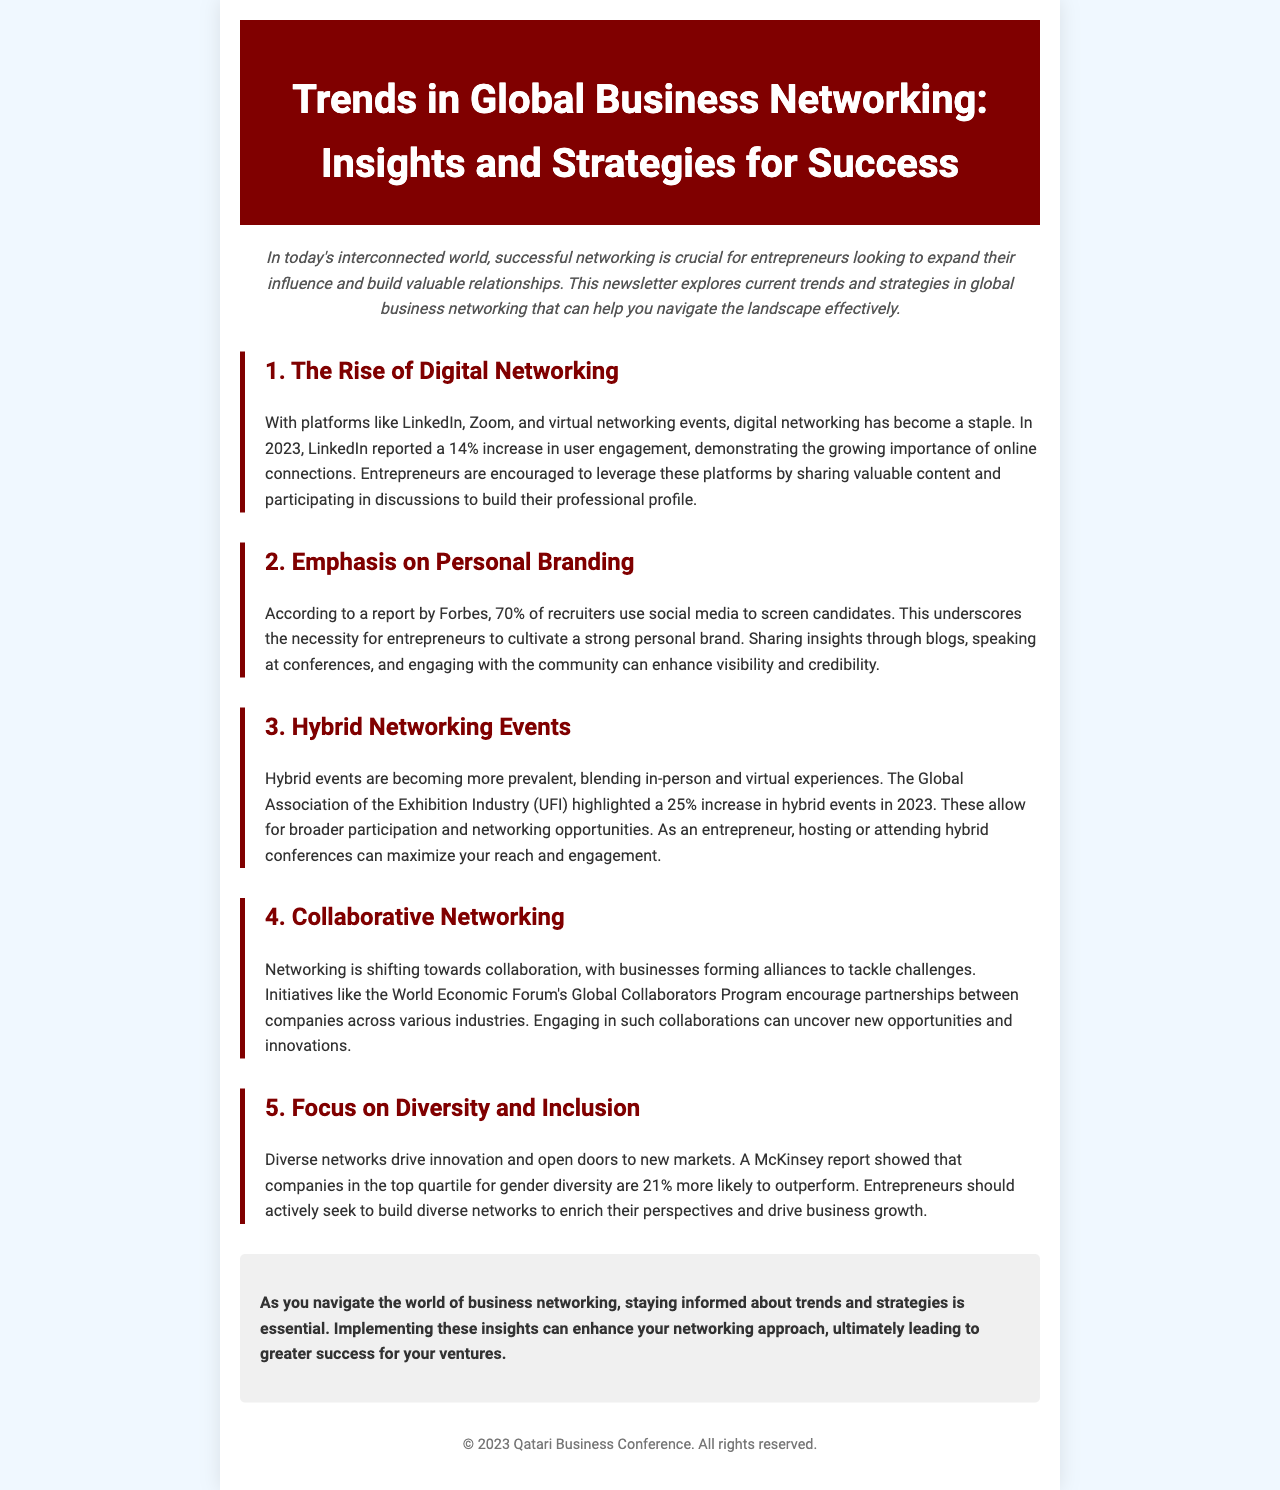what is the percentage increase in LinkedIn user engagement in 2023? The document states that LinkedIn reported a 14% increase in user engagement in 2023.
Answer: 14% what is the primary focus of the section on Personal Branding? The section emphasizes the necessity for entrepreneurs to cultivate a strong personal brand, noting that 70% of recruiters use social media to screen candidates.
Answer: Personal branding how much did hybrid events increase in prevalence in 2023? The Global Association of the Exhibition Industry highlighted a 25% increase in hybrid events in 2023.
Answer: 25% what program encourages partnerships between companies across various industries? The document mentions the World Economic Forum's Global Collaborators Program as an initiative that encourages such partnerships.
Answer: Global Collaborators Program which report indicates that companies with higher gender diversity are more likely to outperform? A McKinsey report is cited in the document, showing that companies in the top quartile for gender diversity are 21% more likely to outperform.
Answer: McKinsey report what is the main benefit of building diverse networks according to the document? It states that diverse networks drive innovation and open doors to new markets.
Answer: Innovation what year is considered crucial for entrepreneurs looking to expand their influence? The newsletter discusses current trends and strategies for success in global business networking in 2023.
Answer: 2023 what type of networking events blend in-person and virtual experiences? The document refers to them as hybrid events.
Answer: Hybrid events 